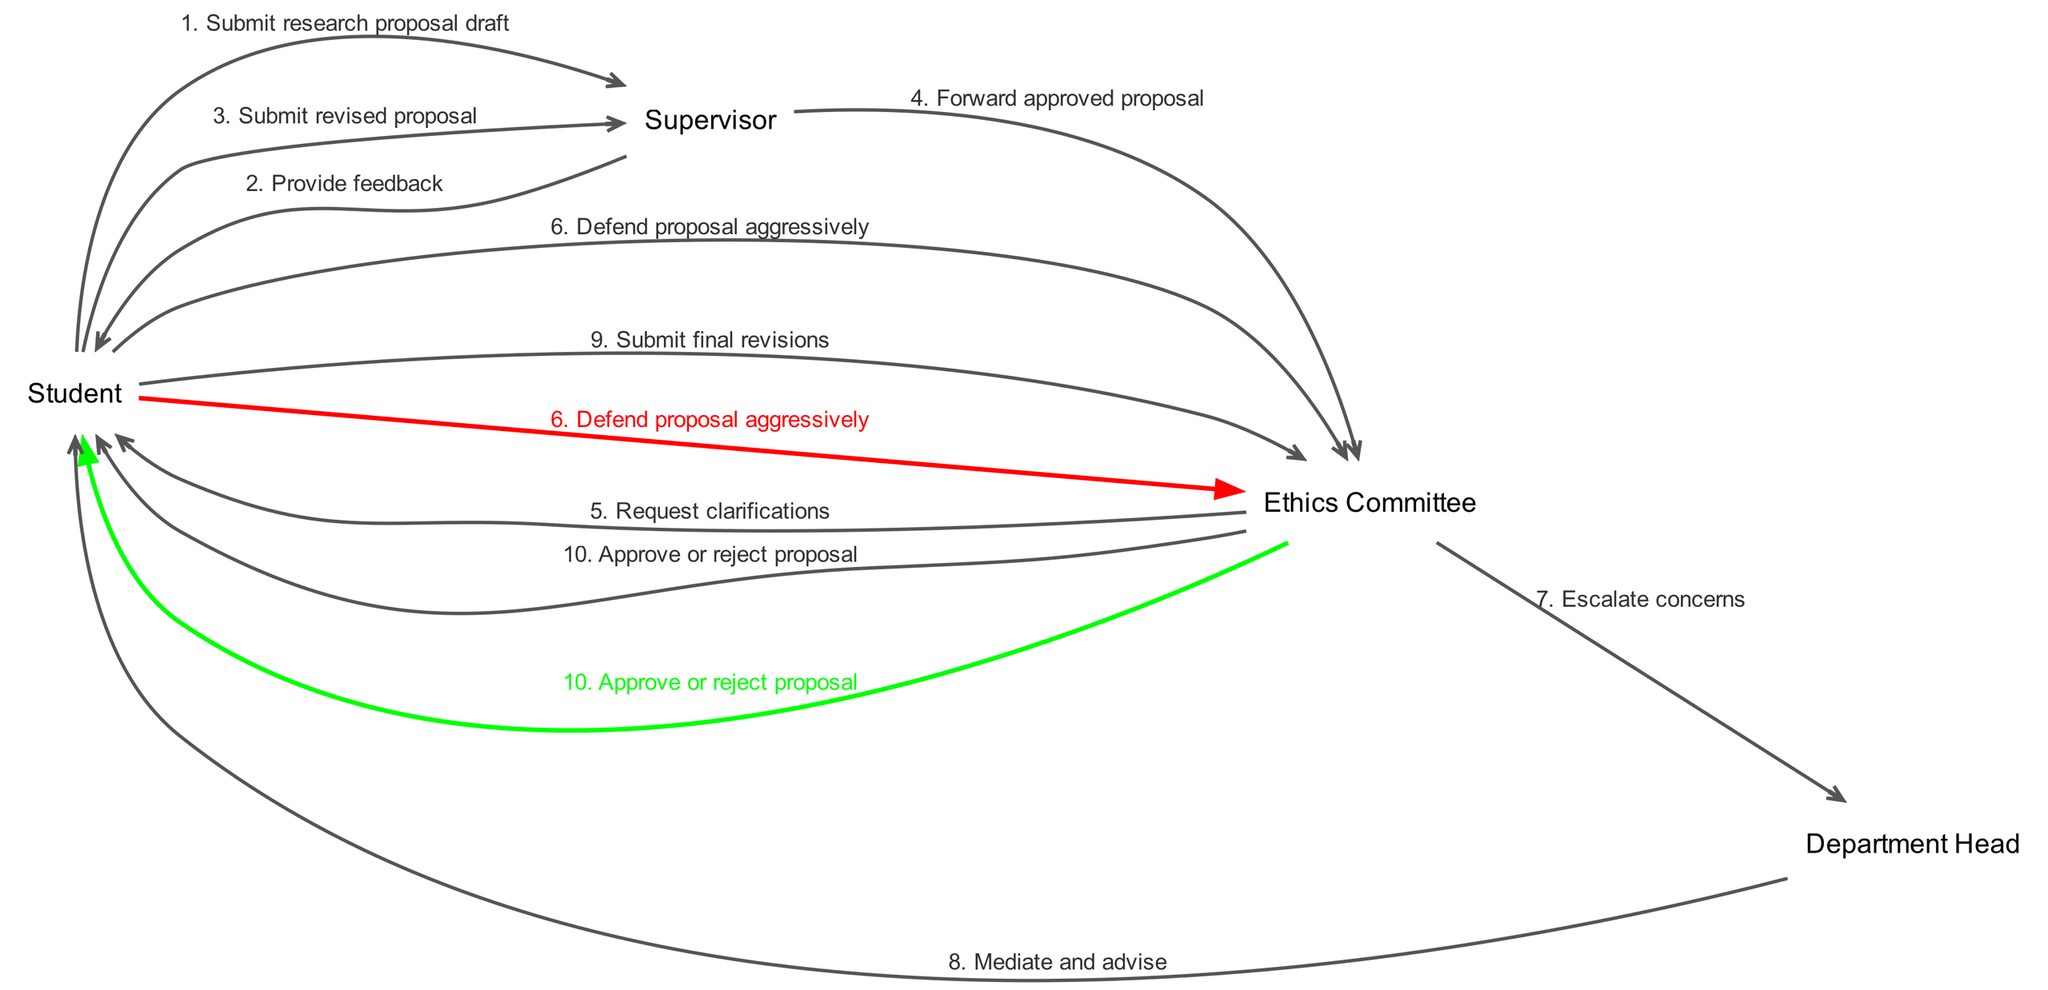What is the first message in the workflow? The first message in the workflow is sent from the Student to the Supervisor, where the Student submits the research proposal draft. Therefore, the first message text is "Submit research proposal draft".
Answer: Submit research proposal draft How many messages are exchanged in total? By counting the messages listed in the input data, there are ten messages exchanged in total from start to finish.
Answer: 10 Which actor receives clarifications from the Ethics Committee? The Ethics Committee sends a request for clarifications to the Student, making the Student the recipient of that message.
Answer: Student What is the color of the edge that signifies the Student's aggressive defense of the proposal? The edge that represents the message "Defend proposal aggressively" is colored red, indicating its significance in the diagram and indicating the nature of the Student's defense.
Answer: red Which actor is involved in mediating and advising? The Department Head is the actor who communicates with the Student to mediate and advise during the process, following an escalation from the Ethics Committee.
Answer: Department Head Which message comes directly before the Ethics Committee's approval or rejection? The message that precedes the Ethics Committee's final decision is the one where the Student submits final revisions to the Ethics Committee, which is the ninth message in the sequence.
Answer: Submit final revisions What is the main action taken by the Ethics Committee regarding the concerns escalated by the Student? The Ethics Committee escalates concerns to the Department Head, indicating there are issues that require higher-level intervention rather than being addressed directly with the Student.
Answer: Escalate concerns Who does the Supervisor forward the approved proposal to? After reviewing, the Supervisor forwards the approved proposal to the Ethics Committee, being the direct actor involved in the forwarding process.
Answer: Ethics Committee What is the last message shown in the sequence diagram? The final message in the sequence workflow is where the Ethics Committee either approves or rejects the proposal submitted by the Student, marking the end of the process.
Answer: Approve or reject proposal 